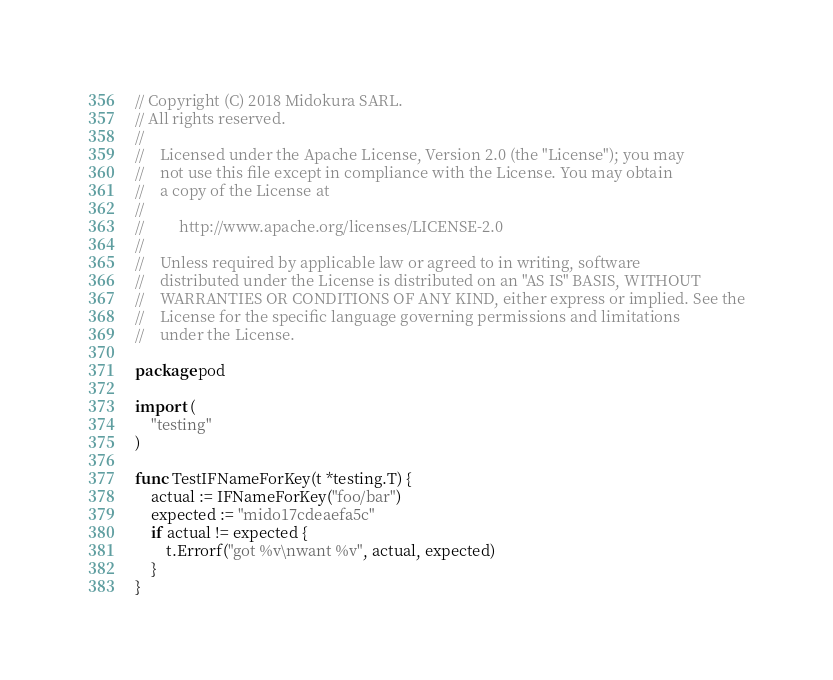Convert code to text. <code><loc_0><loc_0><loc_500><loc_500><_Go_>// Copyright (C) 2018 Midokura SARL.
// All rights reserved.
//
//    Licensed under the Apache License, Version 2.0 (the "License"); you may
//    not use this file except in compliance with the License. You may obtain
//    a copy of the License at
//
//         http://www.apache.org/licenses/LICENSE-2.0
//
//    Unless required by applicable law or agreed to in writing, software
//    distributed under the License is distributed on an "AS IS" BASIS, WITHOUT
//    WARRANTIES OR CONDITIONS OF ANY KIND, either express or implied. See the
//    License for the specific language governing permissions and limitations
//    under the License.

package pod

import (
	"testing"
)

func TestIFNameForKey(t *testing.T) {
	actual := IFNameForKey("foo/bar")
	expected := "mido17cdeaefa5c"
	if actual != expected {
		t.Errorf("got %v\nwant %v", actual, expected)
	}
}
</code> 